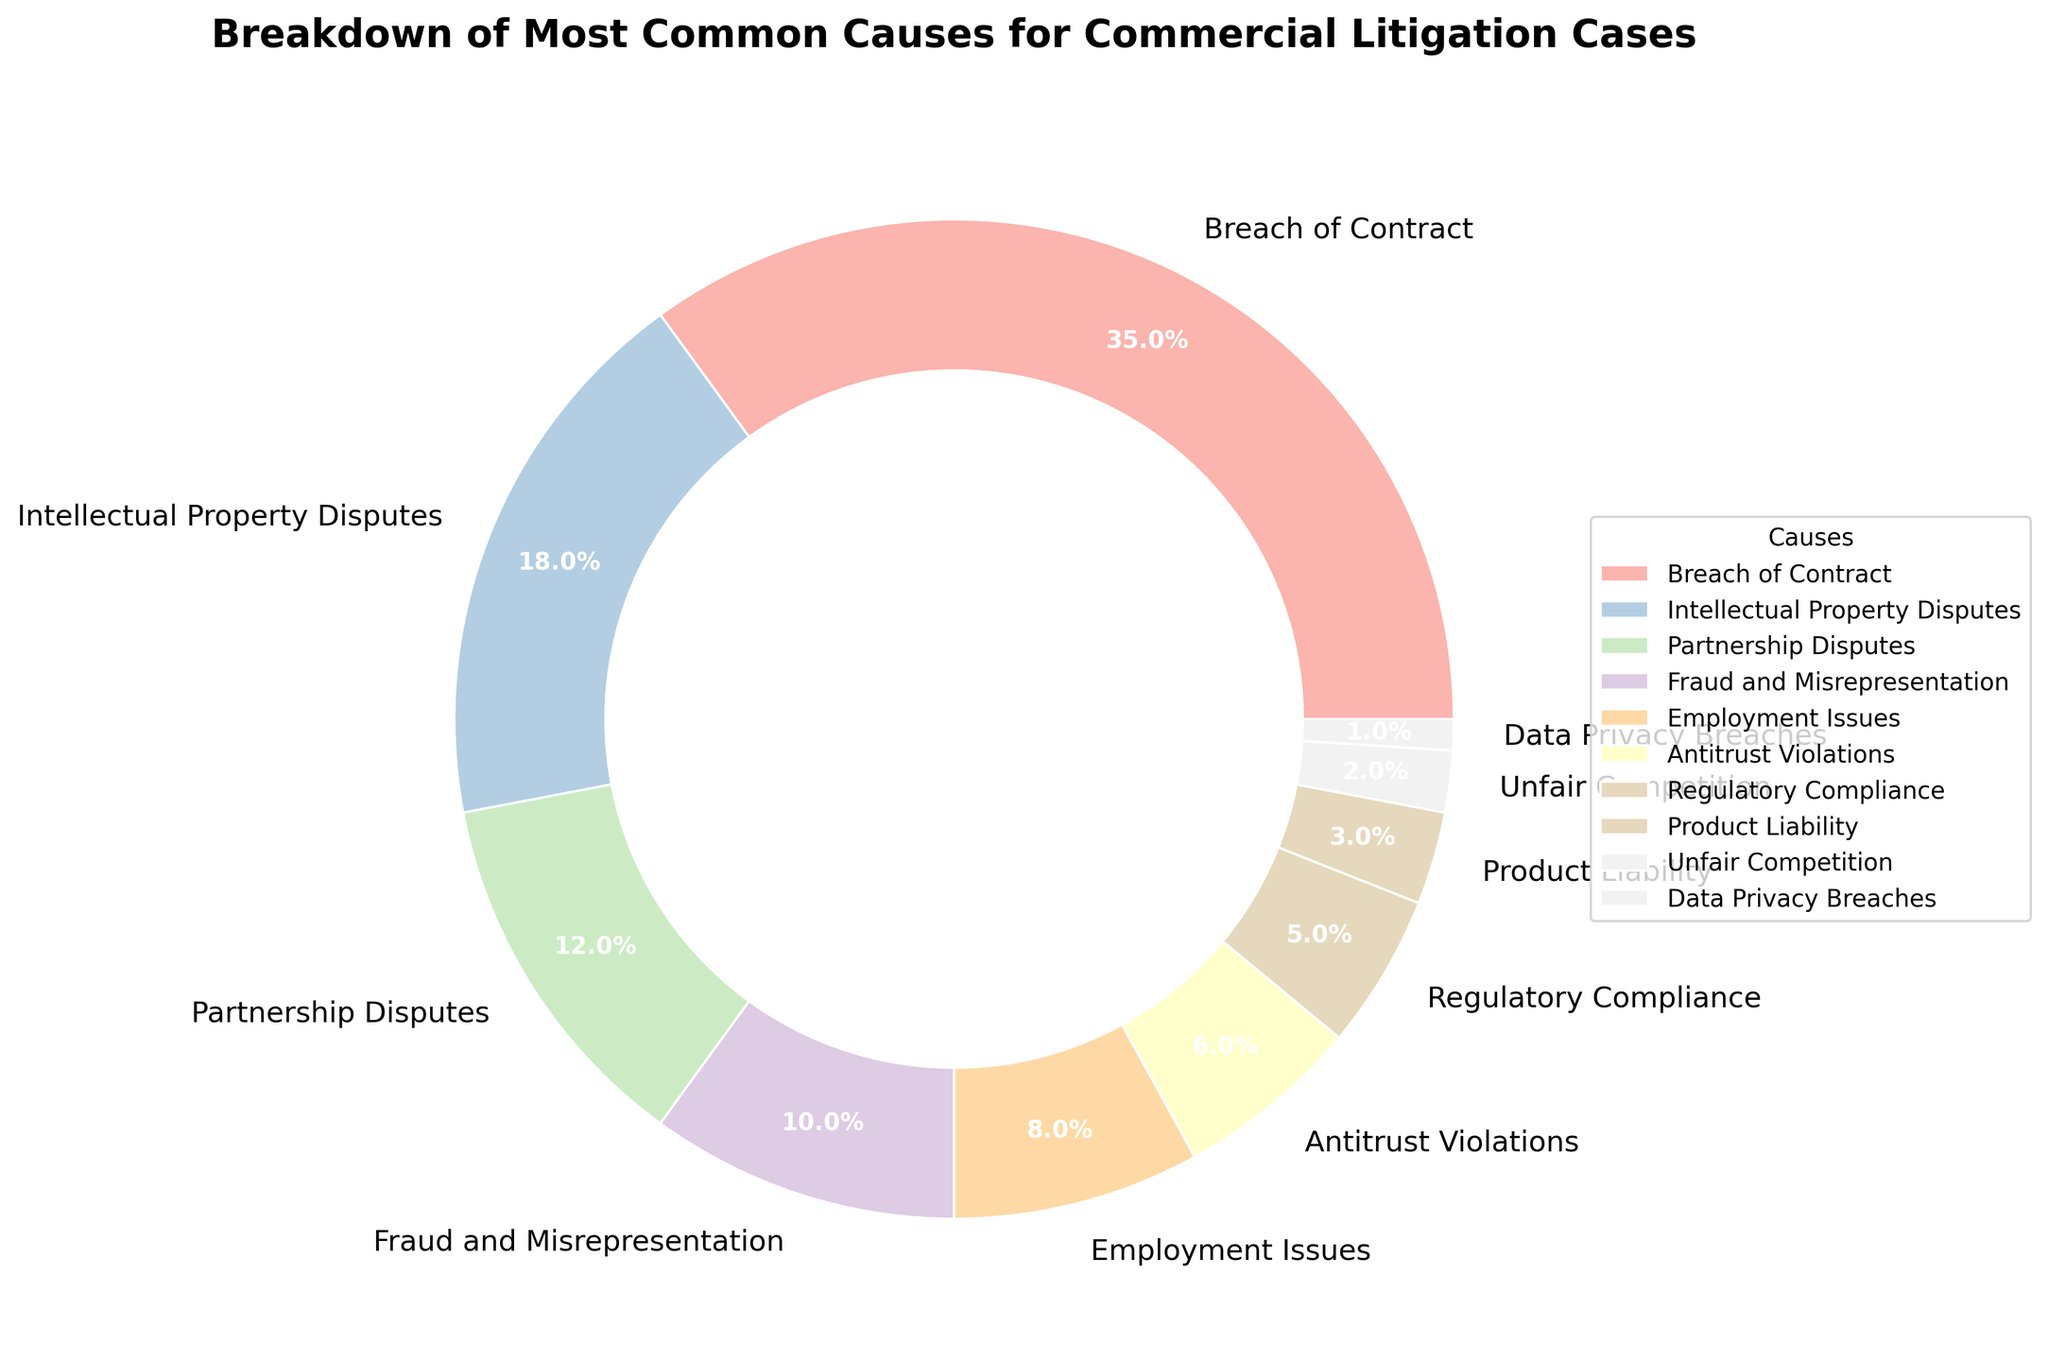Which cause is the most common for commercial litigation cases? The most common cause is the one with the largest percentage in the figure. Here, 'Breach of Contract' has the largest portion of the pie chart.
Answer: Breach of Contract What is the combined percentage for Antitrust Violations and Regulatory Compliance? To find the combined percentage, add the individual percentages of 'Antitrust Violations' and 'Regulatory Compliance'. This is 6% + 5%.
Answer: 11% Which cause has a smaller percentage, Unfair Competition or Data Privacy Breaches? Compare the slices representing 'Unfair Competition' and 'Data Privacy Breaches' on the pie chart. 'Data Privacy Breaches' has a smaller slice.
Answer: Data Privacy Breaches How much larger is the percentage for Intellectual Property Disputes compared to Employment Issues? Subtract the percentage of 'Employment Issues' from that of 'Intellectual Property Disputes'. This is 18% - 8%.
Answer: 10% Which causes have a percentage of less than 5%? Identify the causes whose slices in the pie chart represent less than 5%. These are 'Product Liability', 'Unfair Competition', and 'Data Privacy Breaches'.
Answer: Product Liability, Unfair Competition, Data Privacy Breaches What is the combined percentage of the three least common causes? Add the percentages for the three causes with the smallest slices: 'Product Liability', 'Unfair Competition', and 'Data Privacy Breaches'. This is 3% + 2% + 1%.
Answer: 6% What is the total percentage of causes related to financial disputes (Breach of Contract, Fraud and Misrepresentation)? Add the percentages for 'Breach of Contract' and 'Fraud and Misrepresentation'. This is 35% + 10%.
Answer: 45% Which cause occupies the second largest slice of the pie chart? Identify the cause with the second-largest percentage after 'Breach of Contract'. This is 'Intellectual Property Disputes'.
Answer: Intellectual Property Disputes 